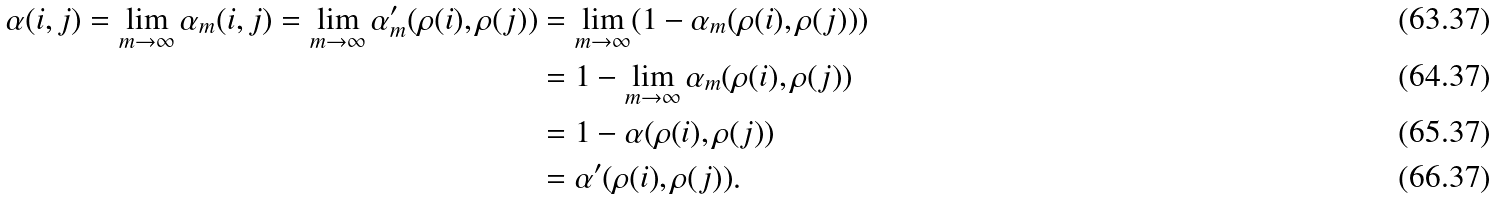Convert formula to latex. <formula><loc_0><loc_0><loc_500><loc_500>\alpha ( i , j ) = \lim _ { m \to \infty } \alpha _ { m } ( i , j ) = \lim _ { m \to \infty } \alpha _ { m } ^ { \prime } ( \rho ( i ) , \rho ( j ) ) & = \lim _ { m \to \infty } ( 1 - \alpha _ { m } ( \rho ( i ) , \rho ( j ) ) ) \\ & = 1 - \lim _ { m \to \infty } \alpha _ { m } ( \rho ( i ) , \rho ( j ) ) \\ & = 1 - \alpha ( \rho ( i ) , \rho ( j ) ) \\ & = \alpha ^ { \prime } ( \rho ( i ) , \rho ( j ) ) .</formula> 